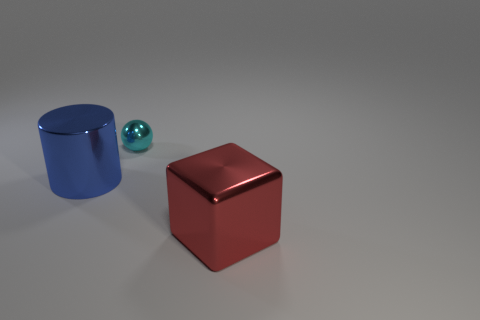Add 3 small cyan spheres. How many objects exist? 6 Subtract all balls. How many objects are left? 2 Add 3 small brown objects. How many small brown objects exist? 3 Subtract 1 cyan balls. How many objects are left? 2 Subtract all tiny green rubber balls. Subtract all blocks. How many objects are left? 2 Add 2 shiny blocks. How many shiny blocks are left? 3 